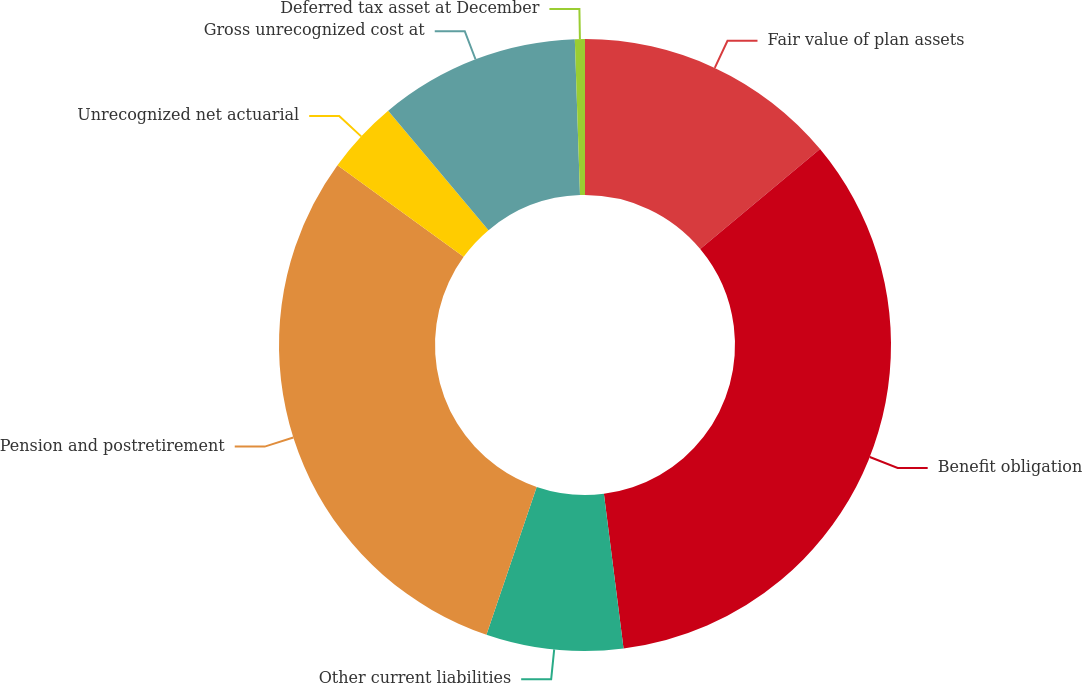<chart> <loc_0><loc_0><loc_500><loc_500><pie_chart><fcel>Fair value of plan assets<fcel>Benefit obligation<fcel>Other current liabilities<fcel>Pension and postretirement<fcel>Unrecognized net actuarial<fcel>Gross unrecognized cost at<fcel>Deferred tax asset at December<nl><fcel>13.94%<fcel>34.05%<fcel>7.23%<fcel>29.78%<fcel>3.88%<fcel>10.59%<fcel>0.53%<nl></chart> 